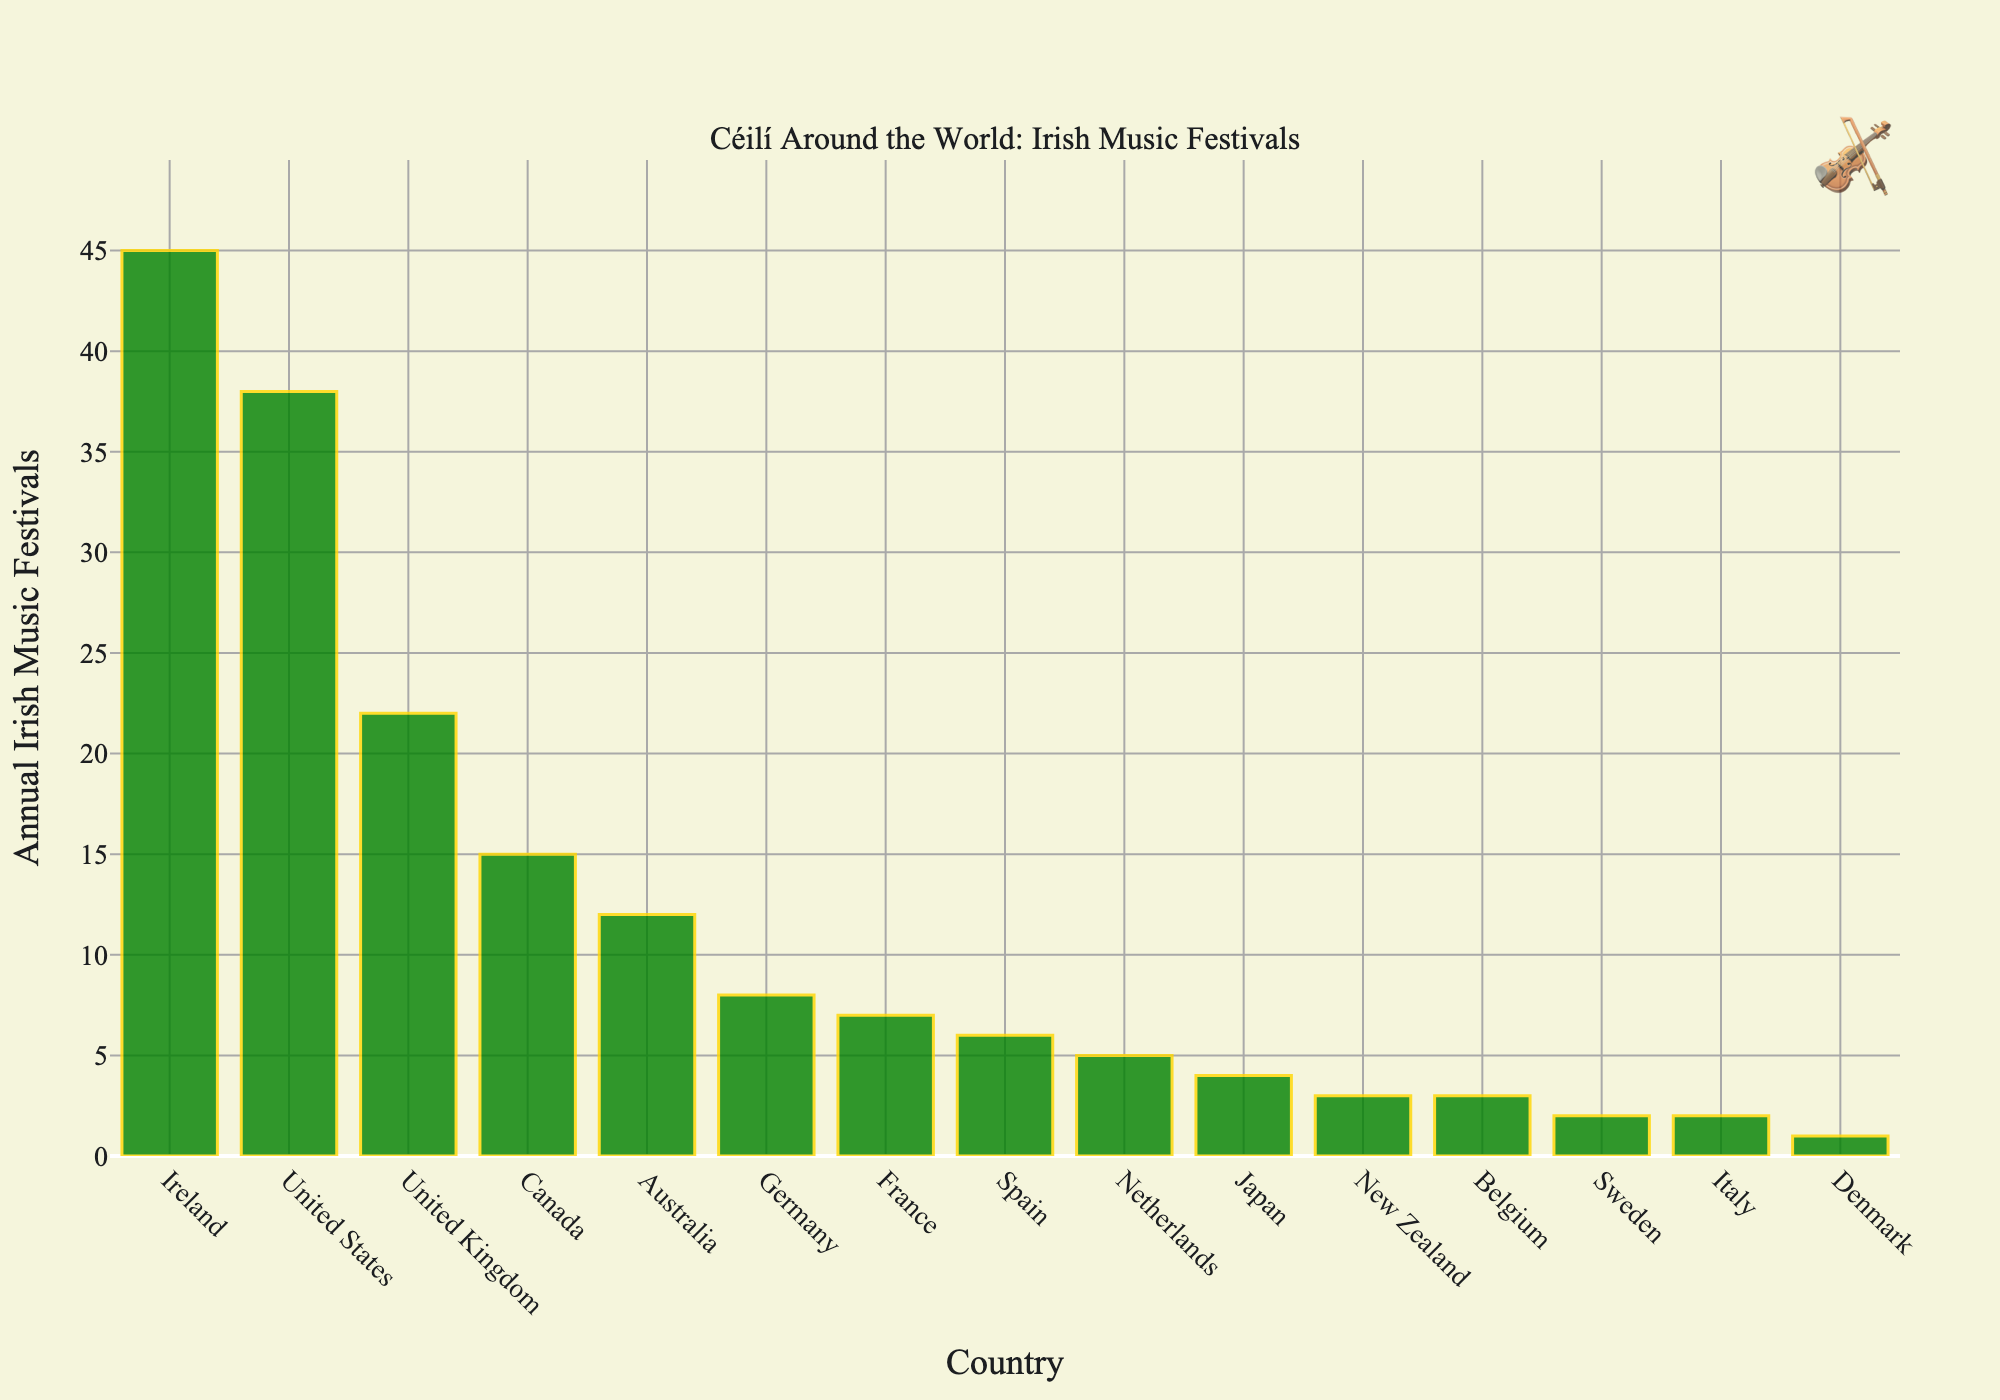Which country hosts the most Irish music festivals annually? The tallest bar represents the country with the highest number of festivals. Here, the tallest bar corresponds to Ireland, indicating it hosts the most festivals.
Answer: Ireland Which two countries feature the least number of annual Irish music festivals, and how many do they host? The two shortest bars in the chart represent the countries with the least festivals. Denmark and Sweden each host the least number of festivals. Denmark hosts 1 festival, while Sweden hosts 2.
Answer: Denmark (1), Sweden (2) How many more Irish music festivals are held in Ireland compared to Japan? Find the height of the bars for Ireland and Japan and subtract the number of festivals in Japan from Ireland. Ireland has 45 festivals, and Japan has 4, so the difference is 45 - 4 = 41.
Answer: 41 Do the United States and Canada together host more Irish music festivals than the United Kingdom and Australia combined? Sum the festivals for the United States (38) and Canada (15), and likewise for the United Kingdom (22) and Australia (12). Compare the totals: 38 + 15 = 53 and 22 + 12 = 34. 53 is greater than 34.
Answer: Yes Which of the countries in Europe (excluding Ireland) holds the highest number of Irish music festivals, and what is the count? Identify the European countries from the chart and find the one with the highest bar. The United Kingdom holds the highest number of festivals in Europe (excluding Ireland) with 22.
Answer: United Kingdom (22) What's the total number of Irish music festivals happening in the top three countries? Add the number of festivals for the top three countries: Ireland (45), United States (38), and United Kingdom (22). The total is 45 + 38 + 22 = 105.
Answer: 105 Which region, North America (United States and Canada) or Oceania (Australia and New Zealand), has more Irish music festivals? Calculate the total festivals for each region. North America: United States (38) + Canada (15) = 53. Oceania: Australia (12) + New Zealand (3) = 15. 53 is greater than 15.
Answer: North America What is the average number of Irish music festivals held across all countries listed? Sum the number of festivals for all countries and divide by the number of countries. Total = 173, Countries = 15, Average = 173 / 15 ≈ 11.53.
Answer: Approximately 11.53 By how much does the count of Irish music festivals in France exceed those in Belgium? Subtract the number of festivals in Belgium from those in France. France has 7, Belgium has 3, so 7 - 3 = 4.
Answer: 4 Is the number of festivals in Germany closer to those in Canada or France? Calculate the difference for each comparison. Germany (8) - Canada (15) = 7; Germany (8) - France (7) = 1. The difference is smaller with France.
Answer: France 